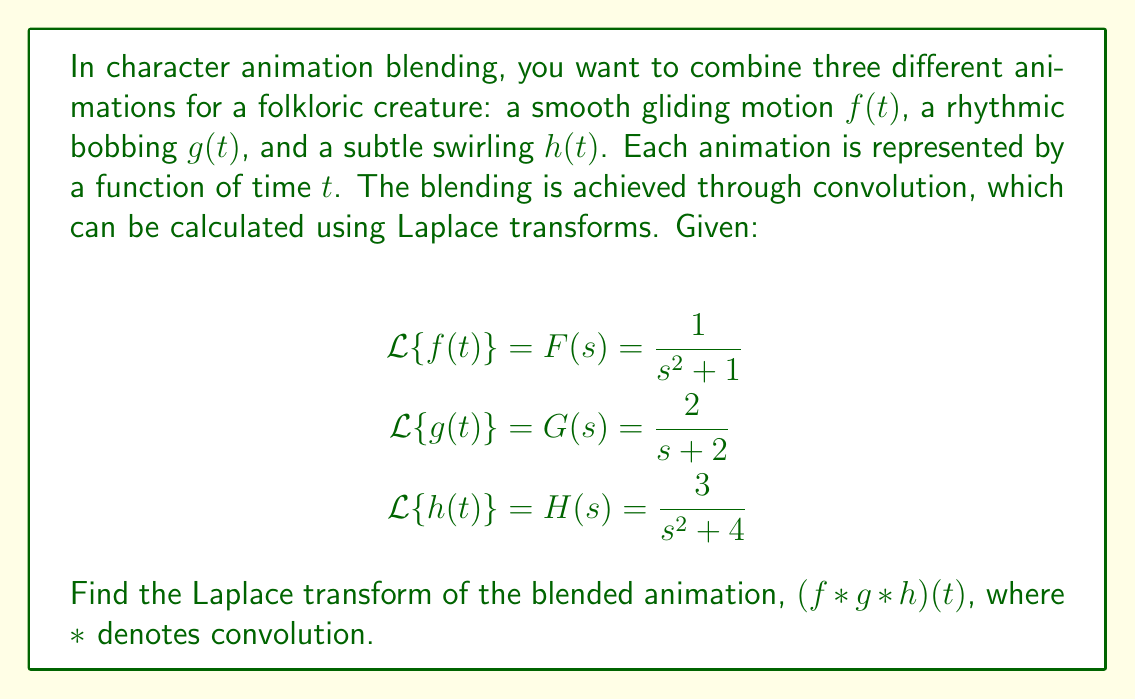Could you help me with this problem? To solve this problem, we'll use the convolution theorem with Laplace transforms. The theorem states that the Laplace transform of a convolution of functions is equal to the product of their individual Laplace transforms.

Given:
$\mathcal{L}\{f(t)\} = F(s) = \frac{1}{s^2 + 1}$
$\mathcal{L}\{g(t)\} = G(s) = \frac{2}{s + 2}$
$\mathcal{L}\{h(t)\} = H(s) = \frac{3}{s^2 + 4}$

Step 1: Apply the convolution theorem
$\mathcal{L}\{(f * g * h)(t)\} = F(s) \cdot G(s) \cdot H(s)$

Step 2: Multiply the given Laplace transforms
$$\begin{aligned}
\mathcal{L}\{(f * g * h)(t)\} &= \frac{1}{s^2 + 1} \cdot \frac{2}{s + 2} \cdot \frac{3}{s^2 + 4} \\
&= \frac{1 \cdot 2 \cdot 3}{(s^2 + 1)(s + 2)(s^2 + 4)} \\
&= \frac{6}{(s^2 + 1)(s + 2)(s^2 + 4)}
\end{aligned}$$

Step 3: Simplify the expression (if possible)
In this case, further simplification is not practical without partial fraction decomposition, which is beyond the scope of this question. Therefore, we'll leave the result in its current form.
Answer: $\mathcal{L}\{(f * g * h)(t)\} = \frac{6}{(s^2 + 1)(s + 2)(s^2 + 4)}$ 